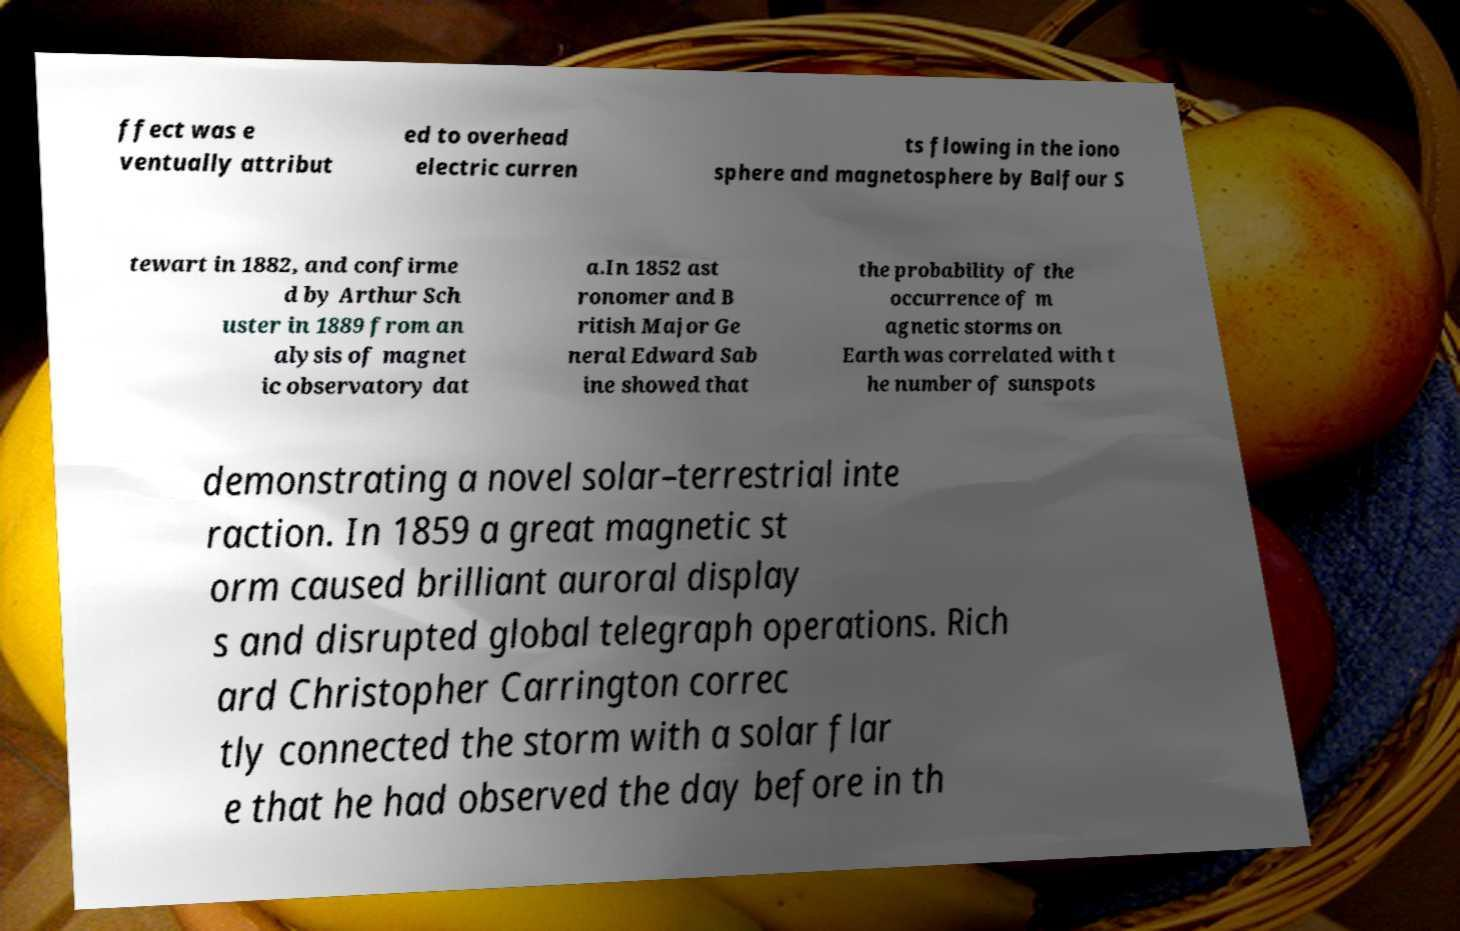What messages or text are displayed in this image? I need them in a readable, typed format. ffect was e ventually attribut ed to overhead electric curren ts flowing in the iono sphere and magnetosphere by Balfour S tewart in 1882, and confirme d by Arthur Sch uster in 1889 from an alysis of magnet ic observatory dat a.In 1852 ast ronomer and B ritish Major Ge neral Edward Sab ine showed that the probability of the occurrence of m agnetic storms on Earth was correlated with t he number of sunspots demonstrating a novel solar–terrestrial inte raction. In 1859 a great magnetic st orm caused brilliant auroral display s and disrupted global telegraph operations. Rich ard Christopher Carrington correc tly connected the storm with a solar flar e that he had observed the day before in th 